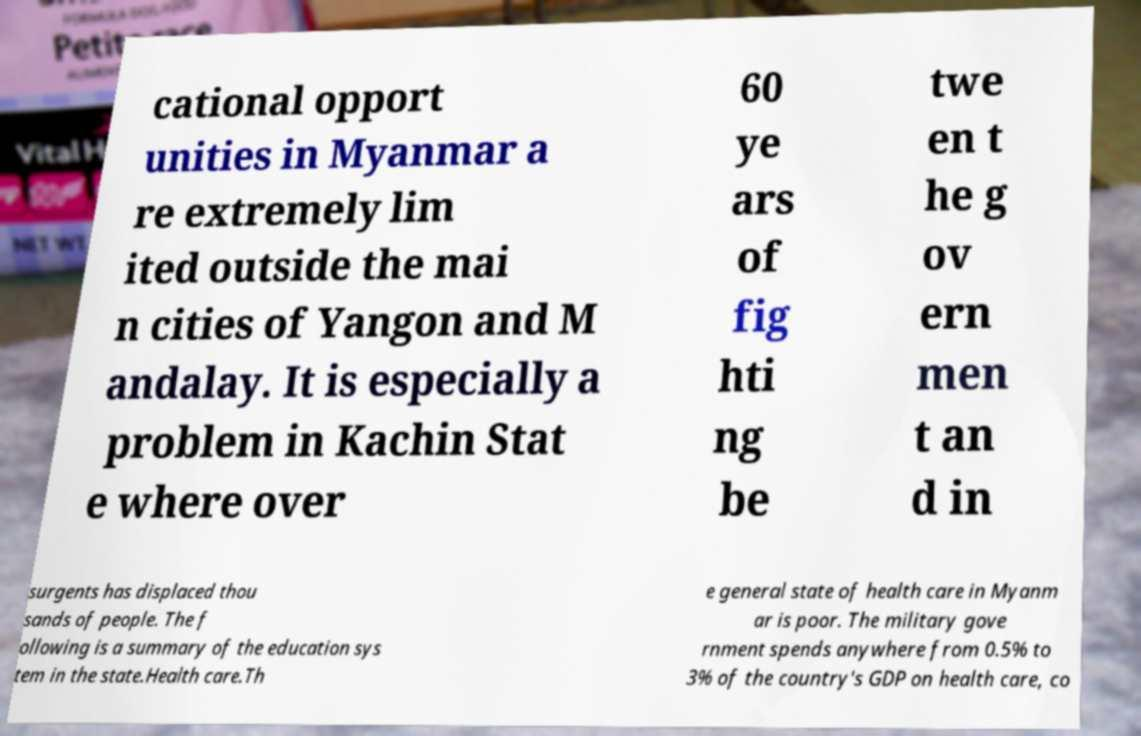Could you extract and type out the text from this image? cational opport unities in Myanmar a re extremely lim ited outside the mai n cities of Yangon and M andalay. It is especially a problem in Kachin Stat e where over 60 ye ars of fig hti ng be twe en t he g ov ern men t an d in surgents has displaced thou sands of people. The f ollowing is a summary of the education sys tem in the state.Health care.Th e general state of health care in Myanm ar is poor. The military gove rnment spends anywhere from 0.5% to 3% of the country's GDP on health care, co 